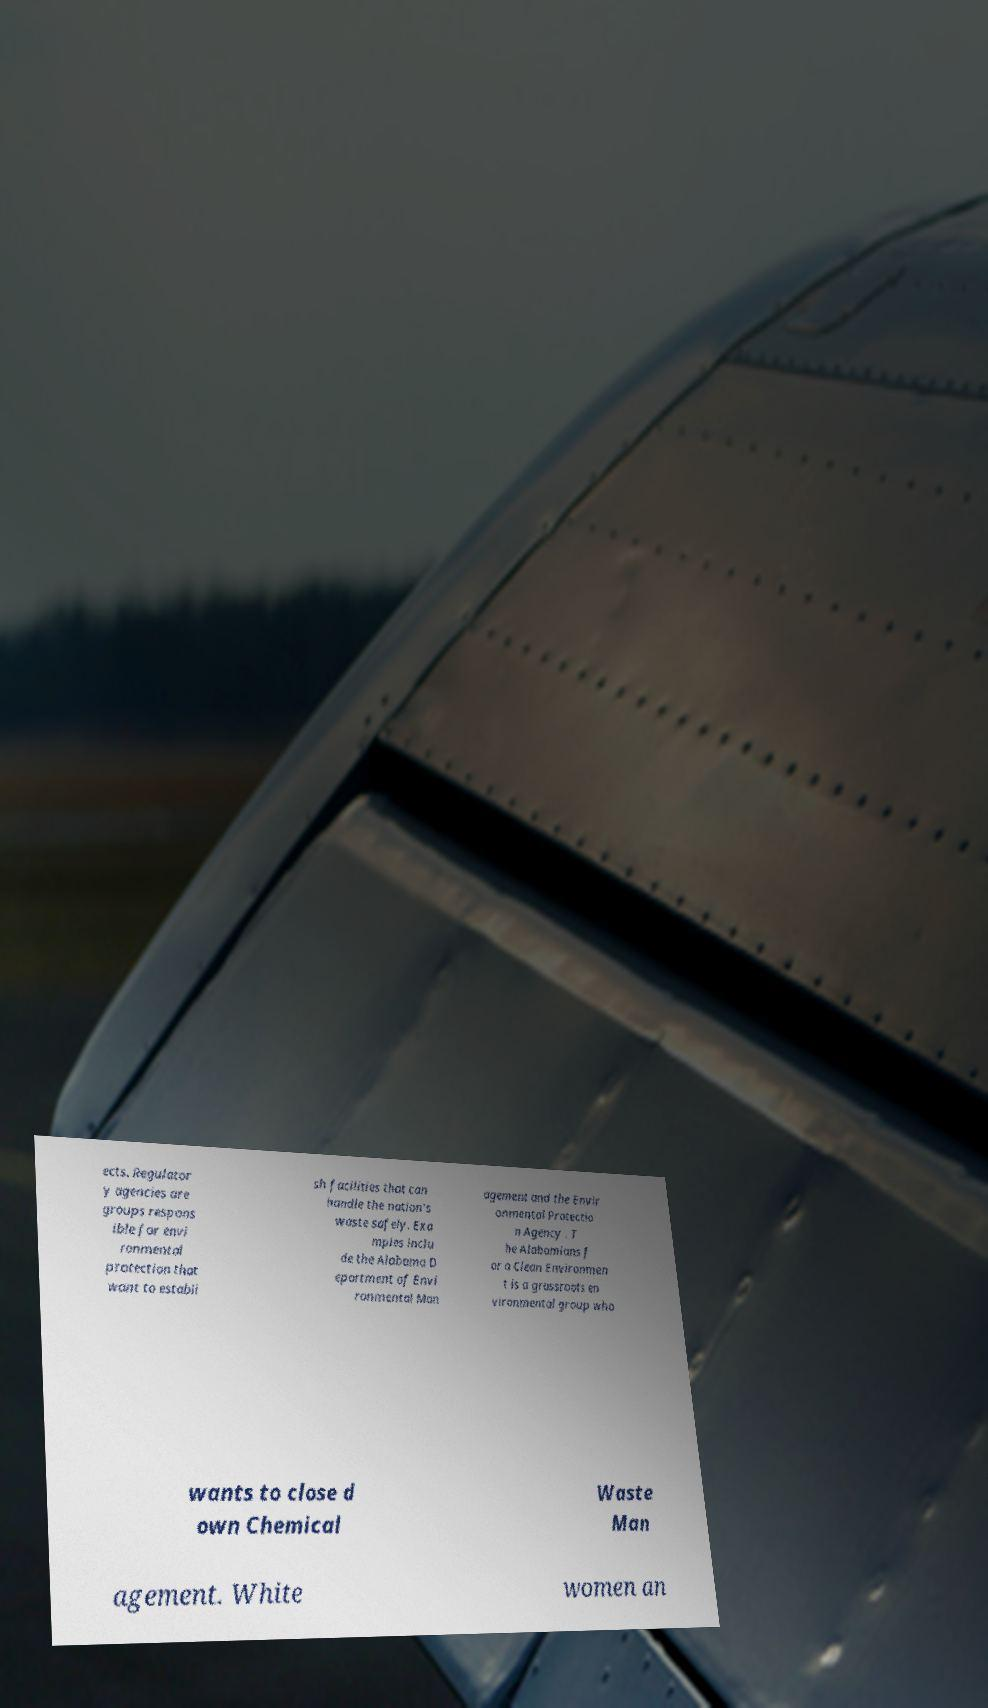Please read and relay the text visible in this image. What does it say? ects. Regulator y agencies are groups respons ible for envi ronmental protection that want to establi sh facilities that can handle the nation's waste safely. Exa mples inclu de the Alabama D epartment of Envi ronmental Man agement and the Envir onmental Protectio n Agency . T he Alabamians f or a Clean Environmen t is a grassroots en vironmental group who wants to close d own Chemical Waste Man agement. White women an 